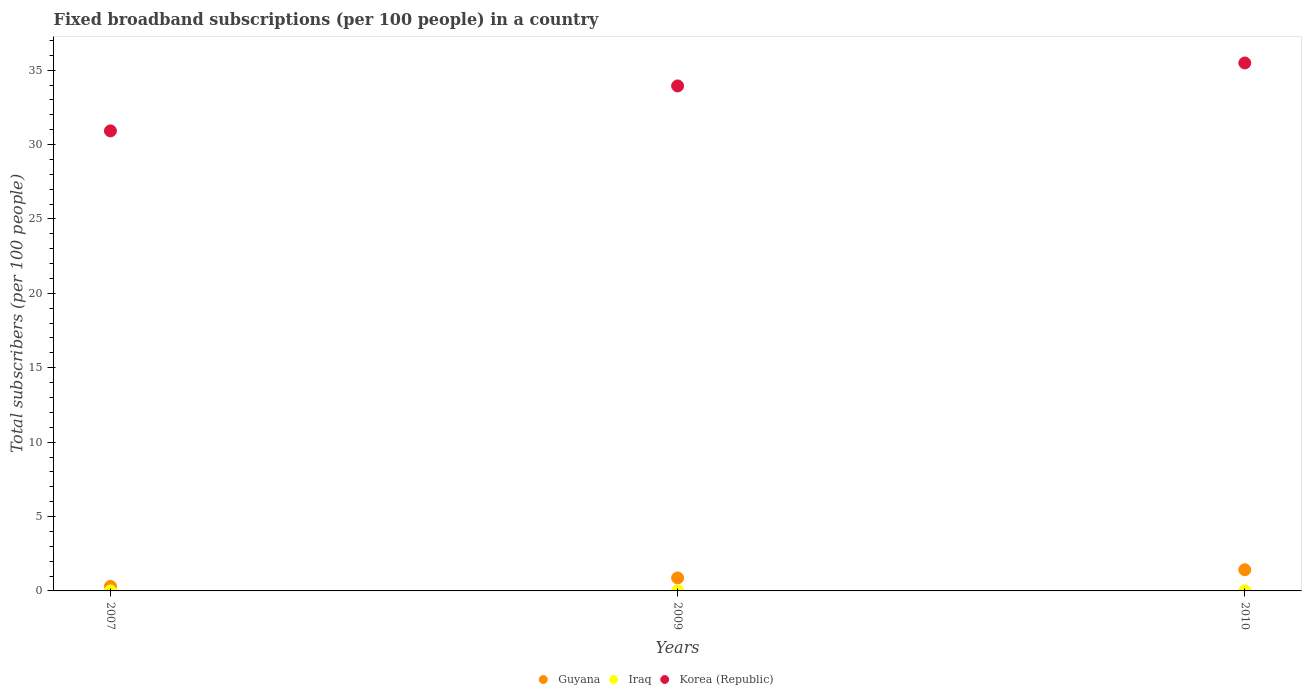How many different coloured dotlines are there?
Offer a very short reply. 3. What is the number of broadband subscriptions in Guyana in 2007?
Provide a short and direct response. 0.31. Across all years, what is the maximum number of broadband subscriptions in Guyana?
Provide a succinct answer. 1.42. Across all years, what is the minimum number of broadband subscriptions in Korea (Republic)?
Provide a short and direct response. 30.92. In which year was the number of broadband subscriptions in Korea (Republic) maximum?
Provide a succinct answer. 2010. What is the total number of broadband subscriptions in Iraq in the graph?
Give a very brief answer. 0.01. What is the difference between the number of broadband subscriptions in Guyana in 2007 and that in 2009?
Offer a very short reply. -0.57. What is the difference between the number of broadband subscriptions in Korea (Republic) in 2009 and the number of broadband subscriptions in Iraq in 2010?
Make the answer very short. 33.93. What is the average number of broadband subscriptions in Guyana per year?
Make the answer very short. 0.87. In the year 2009, what is the difference between the number of broadband subscriptions in Guyana and number of broadband subscriptions in Iraq?
Make the answer very short. 0.87. What is the ratio of the number of broadband subscriptions in Guyana in 2009 to that in 2010?
Offer a terse response. 0.61. Is the number of broadband subscriptions in Guyana in 2007 less than that in 2009?
Offer a very short reply. Yes. What is the difference between the highest and the second highest number of broadband subscriptions in Guyana?
Your response must be concise. 0.55. What is the difference between the highest and the lowest number of broadband subscriptions in Iraq?
Keep it short and to the point. 0.01. Does the number of broadband subscriptions in Guyana monotonically increase over the years?
Give a very brief answer. Yes. Is the number of broadband subscriptions in Guyana strictly greater than the number of broadband subscriptions in Iraq over the years?
Provide a succinct answer. Yes. Is the number of broadband subscriptions in Guyana strictly less than the number of broadband subscriptions in Iraq over the years?
Provide a short and direct response. No. How many dotlines are there?
Offer a terse response. 3. How many years are there in the graph?
Offer a terse response. 3. Are the values on the major ticks of Y-axis written in scientific E-notation?
Keep it short and to the point. No. Does the graph contain any zero values?
Keep it short and to the point. No. Does the graph contain grids?
Your response must be concise. No. How are the legend labels stacked?
Your answer should be very brief. Horizontal. What is the title of the graph?
Provide a short and direct response. Fixed broadband subscriptions (per 100 people) in a country. Does "Low income" appear as one of the legend labels in the graph?
Give a very brief answer. No. What is the label or title of the Y-axis?
Offer a terse response. Total subscribers (per 100 people). What is the Total subscribers (per 100 people) in Guyana in 2007?
Ensure brevity in your answer.  0.31. What is the Total subscribers (per 100 people) in Iraq in 2007?
Provide a short and direct response. 0. What is the Total subscribers (per 100 people) in Korea (Republic) in 2007?
Your answer should be compact. 30.92. What is the Total subscribers (per 100 people) in Guyana in 2009?
Offer a very short reply. 0.87. What is the Total subscribers (per 100 people) in Iraq in 2009?
Keep it short and to the point. 0. What is the Total subscribers (per 100 people) of Korea (Republic) in 2009?
Offer a terse response. 33.94. What is the Total subscribers (per 100 people) of Guyana in 2010?
Provide a short and direct response. 1.42. What is the Total subscribers (per 100 people) in Iraq in 2010?
Offer a very short reply. 0.01. What is the Total subscribers (per 100 people) of Korea (Republic) in 2010?
Provide a short and direct response. 35.49. Across all years, what is the maximum Total subscribers (per 100 people) of Guyana?
Offer a terse response. 1.42. Across all years, what is the maximum Total subscribers (per 100 people) of Iraq?
Your answer should be compact. 0.01. Across all years, what is the maximum Total subscribers (per 100 people) of Korea (Republic)?
Ensure brevity in your answer.  35.49. Across all years, what is the minimum Total subscribers (per 100 people) in Guyana?
Your response must be concise. 0.31. Across all years, what is the minimum Total subscribers (per 100 people) in Iraq?
Offer a very short reply. 0. Across all years, what is the minimum Total subscribers (per 100 people) in Korea (Republic)?
Your answer should be very brief. 30.92. What is the total Total subscribers (per 100 people) of Guyana in the graph?
Provide a succinct answer. 2.6. What is the total Total subscribers (per 100 people) of Iraq in the graph?
Provide a succinct answer. 0.01. What is the total Total subscribers (per 100 people) of Korea (Republic) in the graph?
Give a very brief answer. 100.35. What is the difference between the Total subscribers (per 100 people) in Guyana in 2007 and that in 2009?
Your answer should be compact. -0.57. What is the difference between the Total subscribers (per 100 people) in Iraq in 2007 and that in 2009?
Give a very brief answer. -0. What is the difference between the Total subscribers (per 100 people) of Korea (Republic) in 2007 and that in 2009?
Offer a very short reply. -3.02. What is the difference between the Total subscribers (per 100 people) in Guyana in 2007 and that in 2010?
Keep it short and to the point. -1.12. What is the difference between the Total subscribers (per 100 people) in Iraq in 2007 and that in 2010?
Give a very brief answer. -0.01. What is the difference between the Total subscribers (per 100 people) of Korea (Republic) in 2007 and that in 2010?
Give a very brief answer. -4.56. What is the difference between the Total subscribers (per 100 people) in Guyana in 2009 and that in 2010?
Provide a short and direct response. -0.55. What is the difference between the Total subscribers (per 100 people) of Iraq in 2009 and that in 2010?
Make the answer very short. -0.01. What is the difference between the Total subscribers (per 100 people) in Korea (Republic) in 2009 and that in 2010?
Keep it short and to the point. -1.54. What is the difference between the Total subscribers (per 100 people) in Guyana in 2007 and the Total subscribers (per 100 people) in Iraq in 2009?
Keep it short and to the point. 0.31. What is the difference between the Total subscribers (per 100 people) of Guyana in 2007 and the Total subscribers (per 100 people) of Korea (Republic) in 2009?
Ensure brevity in your answer.  -33.64. What is the difference between the Total subscribers (per 100 people) of Iraq in 2007 and the Total subscribers (per 100 people) of Korea (Republic) in 2009?
Provide a short and direct response. -33.94. What is the difference between the Total subscribers (per 100 people) in Guyana in 2007 and the Total subscribers (per 100 people) in Iraq in 2010?
Offer a terse response. 0.3. What is the difference between the Total subscribers (per 100 people) in Guyana in 2007 and the Total subscribers (per 100 people) in Korea (Republic) in 2010?
Provide a succinct answer. -35.18. What is the difference between the Total subscribers (per 100 people) of Iraq in 2007 and the Total subscribers (per 100 people) of Korea (Republic) in 2010?
Keep it short and to the point. -35.49. What is the difference between the Total subscribers (per 100 people) of Guyana in 2009 and the Total subscribers (per 100 people) of Iraq in 2010?
Ensure brevity in your answer.  0.86. What is the difference between the Total subscribers (per 100 people) of Guyana in 2009 and the Total subscribers (per 100 people) of Korea (Republic) in 2010?
Provide a succinct answer. -34.61. What is the difference between the Total subscribers (per 100 people) of Iraq in 2009 and the Total subscribers (per 100 people) of Korea (Republic) in 2010?
Provide a succinct answer. -35.49. What is the average Total subscribers (per 100 people) in Guyana per year?
Your answer should be very brief. 0.87. What is the average Total subscribers (per 100 people) of Iraq per year?
Make the answer very short. 0. What is the average Total subscribers (per 100 people) in Korea (Republic) per year?
Offer a terse response. 33.45. In the year 2007, what is the difference between the Total subscribers (per 100 people) of Guyana and Total subscribers (per 100 people) of Iraq?
Your answer should be compact. 0.31. In the year 2007, what is the difference between the Total subscribers (per 100 people) of Guyana and Total subscribers (per 100 people) of Korea (Republic)?
Offer a terse response. -30.61. In the year 2007, what is the difference between the Total subscribers (per 100 people) in Iraq and Total subscribers (per 100 people) in Korea (Republic)?
Make the answer very short. -30.92. In the year 2009, what is the difference between the Total subscribers (per 100 people) in Guyana and Total subscribers (per 100 people) in Iraq?
Keep it short and to the point. 0.87. In the year 2009, what is the difference between the Total subscribers (per 100 people) in Guyana and Total subscribers (per 100 people) in Korea (Republic)?
Offer a very short reply. -33.07. In the year 2009, what is the difference between the Total subscribers (per 100 people) in Iraq and Total subscribers (per 100 people) in Korea (Republic)?
Provide a succinct answer. -33.94. In the year 2010, what is the difference between the Total subscribers (per 100 people) of Guyana and Total subscribers (per 100 people) of Iraq?
Keep it short and to the point. 1.41. In the year 2010, what is the difference between the Total subscribers (per 100 people) in Guyana and Total subscribers (per 100 people) in Korea (Republic)?
Keep it short and to the point. -34.06. In the year 2010, what is the difference between the Total subscribers (per 100 people) of Iraq and Total subscribers (per 100 people) of Korea (Republic)?
Provide a succinct answer. -35.48. What is the ratio of the Total subscribers (per 100 people) in Guyana in 2007 to that in 2009?
Provide a succinct answer. 0.35. What is the ratio of the Total subscribers (per 100 people) of Iraq in 2007 to that in 2009?
Offer a terse response. 0.85. What is the ratio of the Total subscribers (per 100 people) of Korea (Republic) in 2007 to that in 2009?
Your answer should be compact. 0.91. What is the ratio of the Total subscribers (per 100 people) of Guyana in 2007 to that in 2010?
Offer a terse response. 0.22. What is the ratio of the Total subscribers (per 100 people) in Iraq in 2007 to that in 2010?
Give a very brief answer. 0.03. What is the ratio of the Total subscribers (per 100 people) in Korea (Republic) in 2007 to that in 2010?
Your answer should be compact. 0.87. What is the ratio of the Total subscribers (per 100 people) of Guyana in 2009 to that in 2010?
Your answer should be very brief. 0.61. What is the ratio of the Total subscribers (per 100 people) of Iraq in 2009 to that in 2010?
Offer a very short reply. 0.04. What is the ratio of the Total subscribers (per 100 people) of Korea (Republic) in 2009 to that in 2010?
Make the answer very short. 0.96. What is the difference between the highest and the second highest Total subscribers (per 100 people) of Guyana?
Your response must be concise. 0.55. What is the difference between the highest and the second highest Total subscribers (per 100 people) of Iraq?
Make the answer very short. 0.01. What is the difference between the highest and the second highest Total subscribers (per 100 people) in Korea (Republic)?
Offer a very short reply. 1.54. What is the difference between the highest and the lowest Total subscribers (per 100 people) of Guyana?
Offer a very short reply. 1.12. What is the difference between the highest and the lowest Total subscribers (per 100 people) in Iraq?
Provide a short and direct response. 0.01. What is the difference between the highest and the lowest Total subscribers (per 100 people) of Korea (Republic)?
Your answer should be compact. 4.56. 